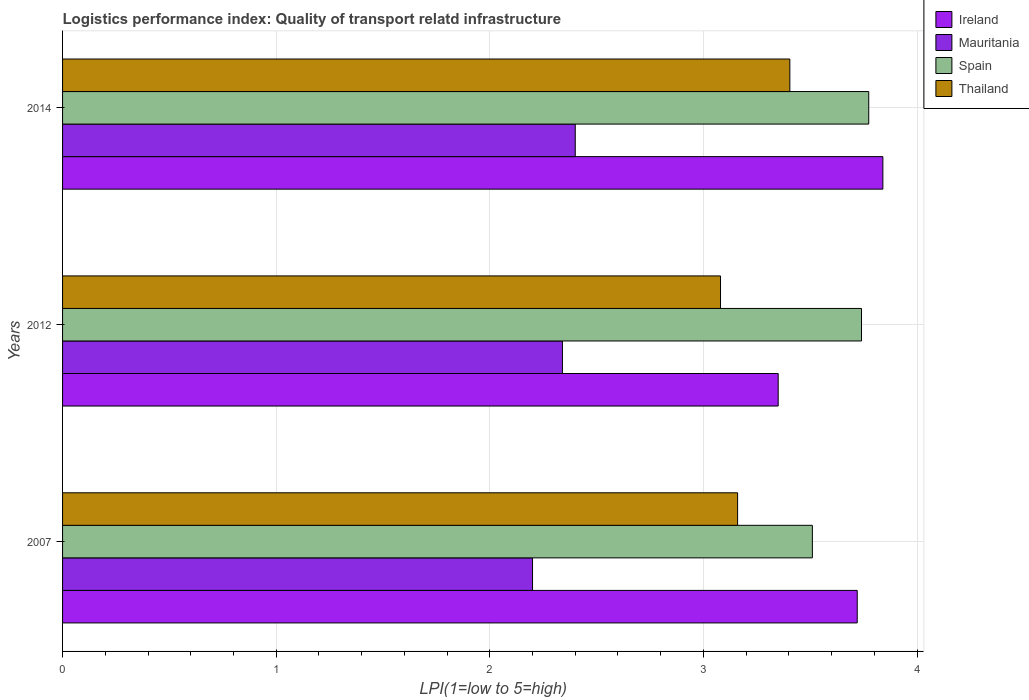How many groups of bars are there?
Give a very brief answer. 3. Are the number of bars on each tick of the Y-axis equal?
Provide a succinct answer. Yes. How many bars are there on the 1st tick from the top?
Your answer should be very brief. 4. How many bars are there on the 3rd tick from the bottom?
Your response must be concise. 4. What is the logistics performance index in Ireland in 2012?
Keep it short and to the point. 3.35. Across all years, what is the maximum logistics performance index in Thailand?
Provide a succinct answer. 3.4. Across all years, what is the minimum logistics performance index in Ireland?
Ensure brevity in your answer.  3.35. In which year was the logistics performance index in Thailand maximum?
Make the answer very short. 2014. In which year was the logistics performance index in Mauritania minimum?
Give a very brief answer. 2007. What is the total logistics performance index in Thailand in the graph?
Ensure brevity in your answer.  9.64. What is the difference between the logistics performance index in Thailand in 2012 and that in 2014?
Your response must be concise. -0.32. What is the difference between the logistics performance index in Thailand in 2014 and the logistics performance index in Ireland in 2012?
Make the answer very short. 0.05. What is the average logistics performance index in Ireland per year?
Give a very brief answer. 3.64. In the year 2014, what is the difference between the logistics performance index in Thailand and logistics performance index in Ireland?
Give a very brief answer. -0.44. In how many years, is the logistics performance index in Thailand greater than 1.6 ?
Your answer should be compact. 3. What is the ratio of the logistics performance index in Thailand in 2012 to that in 2014?
Keep it short and to the point. 0.9. Is the difference between the logistics performance index in Thailand in 2012 and 2014 greater than the difference between the logistics performance index in Ireland in 2012 and 2014?
Provide a short and direct response. Yes. What is the difference between the highest and the second highest logistics performance index in Spain?
Keep it short and to the point. 0.03. What is the difference between the highest and the lowest logistics performance index in Thailand?
Keep it short and to the point. 0.32. In how many years, is the logistics performance index in Spain greater than the average logistics performance index in Spain taken over all years?
Offer a very short reply. 2. Is it the case that in every year, the sum of the logistics performance index in Ireland and logistics performance index in Thailand is greater than the sum of logistics performance index in Spain and logistics performance index in Mauritania?
Offer a terse response. No. What does the 4th bar from the top in 2012 represents?
Your response must be concise. Ireland. What does the 4th bar from the bottom in 2007 represents?
Provide a succinct answer. Thailand. Is it the case that in every year, the sum of the logistics performance index in Ireland and logistics performance index in Spain is greater than the logistics performance index in Mauritania?
Your response must be concise. Yes. How many years are there in the graph?
Offer a terse response. 3. Are the values on the major ticks of X-axis written in scientific E-notation?
Your answer should be very brief. No. Does the graph contain grids?
Offer a terse response. Yes. How many legend labels are there?
Make the answer very short. 4. How are the legend labels stacked?
Your answer should be very brief. Vertical. What is the title of the graph?
Provide a succinct answer. Logistics performance index: Quality of transport relatd infrastructure. What is the label or title of the X-axis?
Provide a succinct answer. LPI(1=low to 5=high). What is the label or title of the Y-axis?
Make the answer very short. Years. What is the LPI(1=low to 5=high) of Ireland in 2007?
Offer a terse response. 3.72. What is the LPI(1=low to 5=high) in Mauritania in 2007?
Offer a terse response. 2.2. What is the LPI(1=low to 5=high) of Spain in 2007?
Offer a terse response. 3.51. What is the LPI(1=low to 5=high) of Thailand in 2007?
Make the answer very short. 3.16. What is the LPI(1=low to 5=high) of Ireland in 2012?
Your answer should be compact. 3.35. What is the LPI(1=low to 5=high) of Mauritania in 2012?
Provide a succinct answer. 2.34. What is the LPI(1=low to 5=high) in Spain in 2012?
Your response must be concise. 3.74. What is the LPI(1=low to 5=high) in Thailand in 2012?
Ensure brevity in your answer.  3.08. What is the LPI(1=low to 5=high) in Ireland in 2014?
Give a very brief answer. 3.84. What is the LPI(1=low to 5=high) in Mauritania in 2014?
Give a very brief answer. 2.4. What is the LPI(1=low to 5=high) in Spain in 2014?
Provide a short and direct response. 3.77. What is the LPI(1=low to 5=high) of Thailand in 2014?
Ensure brevity in your answer.  3.4. Across all years, what is the maximum LPI(1=low to 5=high) in Ireland?
Offer a very short reply. 3.84. Across all years, what is the maximum LPI(1=low to 5=high) of Mauritania?
Offer a terse response. 2.4. Across all years, what is the maximum LPI(1=low to 5=high) of Spain?
Provide a short and direct response. 3.77. Across all years, what is the maximum LPI(1=low to 5=high) of Thailand?
Provide a succinct answer. 3.4. Across all years, what is the minimum LPI(1=low to 5=high) in Ireland?
Give a very brief answer. 3.35. Across all years, what is the minimum LPI(1=low to 5=high) of Spain?
Offer a terse response. 3.51. Across all years, what is the minimum LPI(1=low to 5=high) in Thailand?
Your answer should be very brief. 3.08. What is the total LPI(1=low to 5=high) of Ireland in the graph?
Offer a terse response. 10.91. What is the total LPI(1=low to 5=high) of Mauritania in the graph?
Offer a terse response. 6.94. What is the total LPI(1=low to 5=high) in Spain in the graph?
Give a very brief answer. 11.02. What is the total LPI(1=low to 5=high) of Thailand in the graph?
Ensure brevity in your answer.  9.64. What is the difference between the LPI(1=low to 5=high) in Ireland in 2007 and that in 2012?
Provide a short and direct response. 0.37. What is the difference between the LPI(1=low to 5=high) of Mauritania in 2007 and that in 2012?
Your response must be concise. -0.14. What is the difference between the LPI(1=low to 5=high) in Spain in 2007 and that in 2012?
Offer a very short reply. -0.23. What is the difference between the LPI(1=low to 5=high) in Thailand in 2007 and that in 2012?
Your response must be concise. 0.08. What is the difference between the LPI(1=low to 5=high) in Ireland in 2007 and that in 2014?
Your answer should be compact. -0.12. What is the difference between the LPI(1=low to 5=high) in Mauritania in 2007 and that in 2014?
Your answer should be very brief. -0.2. What is the difference between the LPI(1=low to 5=high) in Spain in 2007 and that in 2014?
Make the answer very short. -0.26. What is the difference between the LPI(1=low to 5=high) of Thailand in 2007 and that in 2014?
Provide a succinct answer. -0.24. What is the difference between the LPI(1=low to 5=high) in Ireland in 2012 and that in 2014?
Keep it short and to the point. -0.49. What is the difference between the LPI(1=low to 5=high) of Mauritania in 2012 and that in 2014?
Give a very brief answer. -0.06. What is the difference between the LPI(1=low to 5=high) in Spain in 2012 and that in 2014?
Your response must be concise. -0.03. What is the difference between the LPI(1=low to 5=high) of Thailand in 2012 and that in 2014?
Provide a short and direct response. -0.32. What is the difference between the LPI(1=low to 5=high) of Ireland in 2007 and the LPI(1=low to 5=high) of Mauritania in 2012?
Give a very brief answer. 1.38. What is the difference between the LPI(1=low to 5=high) of Ireland in 2007 and the LPI(1=low to 5=high) of Spain in 2012?
Your answer should be very brief. -0.02. What is the difference between the LPI(1=low to 5=high) in Ireland in 2007 and the LPI(1=low to 5=high) in Thailand in 2012?
Your answer should be very brief. 0.64. What is the difference between the LPI(1=low to 5=high) of Mauritania in 2007 and the LPI(1=low to 5=high) of Spain in 2012?
Keep it short and to the point. -1.54. What is the difference between the LPI(1=low to 5=high) in Mauritania in 2007 and the LPI(1=low to 5=high) in Thailand in 2012?
Provide a short and direct response. -0.88. What is the difference between the LPI(1=low to 5=high) of Spain in 2007 and the LPI(1=low to 5=high) of Thailand in 2012?
Keep it short and to the point. 0.43. What is the difference between the LPI(1=low to 5=high) of Ireland in 2007 and the LPI(1=low to 5=high) of Mauritania in 2014?
Offer a terse response. 1.32. What is the difference between the LPI(1=low to 5=high) in Ireland in 2007 and the LPI(1=low to 5=high) in Spain in 2014?
Your response must be concise. -0.05. What is the difference between the LPI(1=low to 5=high) of Ireland in 2007 and the LPI(1=low to 5=high) of Thailand in 2014?
Give a very brief answer. 0.32. What is the difference between the LPI(1=low to 5=high) of Mauritania in 2007 and the LPI(1=low to 5=high) of Spain in 2014?
Provide a succinct answer. -1.57. What is the difference between the LPI(1=low to 5=high) in Mauritania in 2007 and the LPI(1=low to 5=high) in Thailand in 2014?
Give a very brief answer. -1.2. What is the difference between the LPI(1=low to 5=high) in Spain in 2007 and the LPI(1=low to 5=high) in Thailand in 2014?
Offer a terse response. 0.11. What is the difference between the LPI(1=low to 5=high) in Ireland in 2012 and the LPI(1=low to 5=high) in Spain in 2014?
Offer a very short reply. -0.42. What is the difference between the LPI(1=low to 5=high) in Ireland in 2012 and the LPI(1=low to 5=high) in Thailand in 2014?
Offer a terse response. -0.05. What is the difference between the LPI(1=low to 5=high) of Mauritania in 2012 and the LPI(1=low to 5=high) of Spain in 2014?
Your answer should be compact. -1.43. What is the difference between the LPI(1=low to 5=high) of Mauritania in 2012 and the LPI(1=low to 5=high) of Thailand in 2014?
Keep it short and to the point. -1.06. What is the difference between the LPI(1=low to 5=high) of Spain in 2012 and the LPI(1=low to 5=high) of Thailand in 2014?
Ensure brevity in your answer.  0.34. What is the average LPI(1=low to 5=high) in Ireland per year?
Your response must be concise. 3.64. What is the average LPI(1=low to 5=high) of Mauritania per year?
Provide a succinct answer. 2.31. What is the average LPI(1=low to 5=high) in Spain per year?
Your answer should be compact. 3.67. What is the average LPI(1=low to 5=high) of Thailand per year?
Your response must be concise. 3.21. In the year 2007, what is the difference between the LPI(1=low to 5=high) in Ireland and LPI(1=low to 5=high) in Mauritania?
Provide a succinct answer. 1.52. In the year 2007, what is the difference between the LPI(1=low to 5=high) in Ireland and LPI(1=low to 5=high) in Spain?
Offer a terse response. 0.21. In the year 2007, what is the difference between the LPI(1=low to 5=high) of Ireland and LPI(1=low to 5=high) of Thailand?
Offer a very short reply. 0.56. In the year 2007, what is the difference between the LPI(1=low to 5=high) of Mauritania and LPI(1=low to 5=high) of Spain?
Your answer should be compact. -1.31. In the year 2007, what is the difference between the LPI(1=low to 5=high) of Mauritania and LPI(1=low to 5=high) of Thailand?
Provide a short and direct response. -0.96. In the year 2007, what is the difference between the LPI(1=low to 5=high) in Spain and LPI(1=low to 5=high) in Thailand?
Keep it short and to the point. 0.35. In the year 2012, what is the difference between the LPI(1=low to 5=high) of Ireland and LPI(1=low to 5=high) of Mauritania?
Offer a very short reply. 1.01. In the year 2012, what is the difference between the LPI(1=low to 5=high) in Ireland and LPI(1=low to 5=high) in Spain?
Your answer should be compact. -0.39. In the year 2012, what is the difference between the LPI(1=low to 5=high) in Ireland and LPI(1=low to 5=high) in Thailand?
Give a very brief answer. 0.27. In the year 2012, what is the difference between the LPI(1=low to 5=high) in Mauritania and LPI(1=low to 5=high) in Thailand?
Offer a very short reply. -0.74. In the year 2012, what is the difference between the LPI(1=low to 5=high) in Spain and LPI(1=low to 5=high) in Thailand?
Provide a short and direct response. 0.66. In the year 2014, what is the difference between the LPI(1=low to 5=high) of Ireland and LPI(1=low to 5=high) of Mauritania?
Offer a terse response. 1.44. In the year 2014, what is the difference between the LPI(1=low to 5=high) in Ireland and LPI(1=low to 5=high) in Spain?
Give a very brief answer. 0.07. In the year 2014, what is the difference between the LPI(1=low to 5=high) of Ireland and LPI(1=low to 5=high) of Thailand?
Ensure brevity in your answer.  0.44. In the year 2014, what is the difference between the LPI(1=low to 5=high) in Mauritania and LPI(1=low to 5=high) in Spain?
Keep it short and to the point. -1.37. In the year 2014, what is the difference between the LPI(1=low to 5=high) of Mauritania and LPI(1=low to 5=high) of Thailand?
Give a very brief answer. -1. In the year 2014, what is the difference between the LPI(1=low to 5=high) in Spain and LPI(1=low to 5=high) in Thailand?
Provide a short and direct response. 0.37. What is the ratio of the LPI(1=low to 5=high) in Ireland in 2007 to that in 2012?
Offer a terse response. 1.11. What is the ratio of the LPI(1=low to 5=high) in Mauritania in 2007 to that in 2012?
Ensure brevity in your answer.  0.94. What is the ratio of the LPI(1=low to 5=high) of Spain in 2007 to that in 2012?
Offer a terse response. 0.94. What is the ratio of the LPI(1=low to 5=high) in Ireland in 2007 to that in 2014?
Your answer should be compact. 0.97. What is the ratio of the LPI(1=low to 5=high) in Spain in 2007 to that in 2014?
Offer a very short reply. 0.93. What is the ratio of the LPI(1=low to 5=high) in Thailand in 2007 to that in 2014?
Your answer should be very brief. 0.93. What is the ratio of the LPI(1=low to 5=high) of Ireland in 2012 to that in 2014?
Your answer should be very brief. 0.87. What is the ratio of the LPI(1=low to 5=high) in Spain in 2012 to that in 2014?
Ensure brevity in your answer.  0.99. What is the ratio of the LPI(1=low to 5=high) of Thailand in 2012 to that in 2014?
Your response must be concise. 0.9. What is the difference between the highest and the second highest LPI(1=low to 5=high) in Ireland?
Offer a terse response. 0.12. What is the difference between the highest and the second highest LPI(1=low to 5=high) in Mauritania?
Ensure brevity in your answer.  0.06. What is the difference between the highest and the second highest LPI(1=low to 5=high) in Spain?
Ensure brevity in your answer.  0.03. What is the difference between the highest and the second highest LPI(1=low to 5=high) of Thailand?
Provide a short and direct response. 0.24. What is the difference between the highest and the lowest LPI(1=low to 5=high) in Ireland?
Your response must be concise. 0.49. What is the difference between the highest and the lowest LPI(1=low to 5=high) in Mauritania?
Provide a succinct answer. 0.2. What is the difference between the highest and the lowest LPI(1=low to 5=high) in Spain?
Give a very brief answer. 0.26. What is the difference between the highest and the lowest LPI(1=low to 5=high) in Thailand?
Keep it short and to the point. 0.32. 